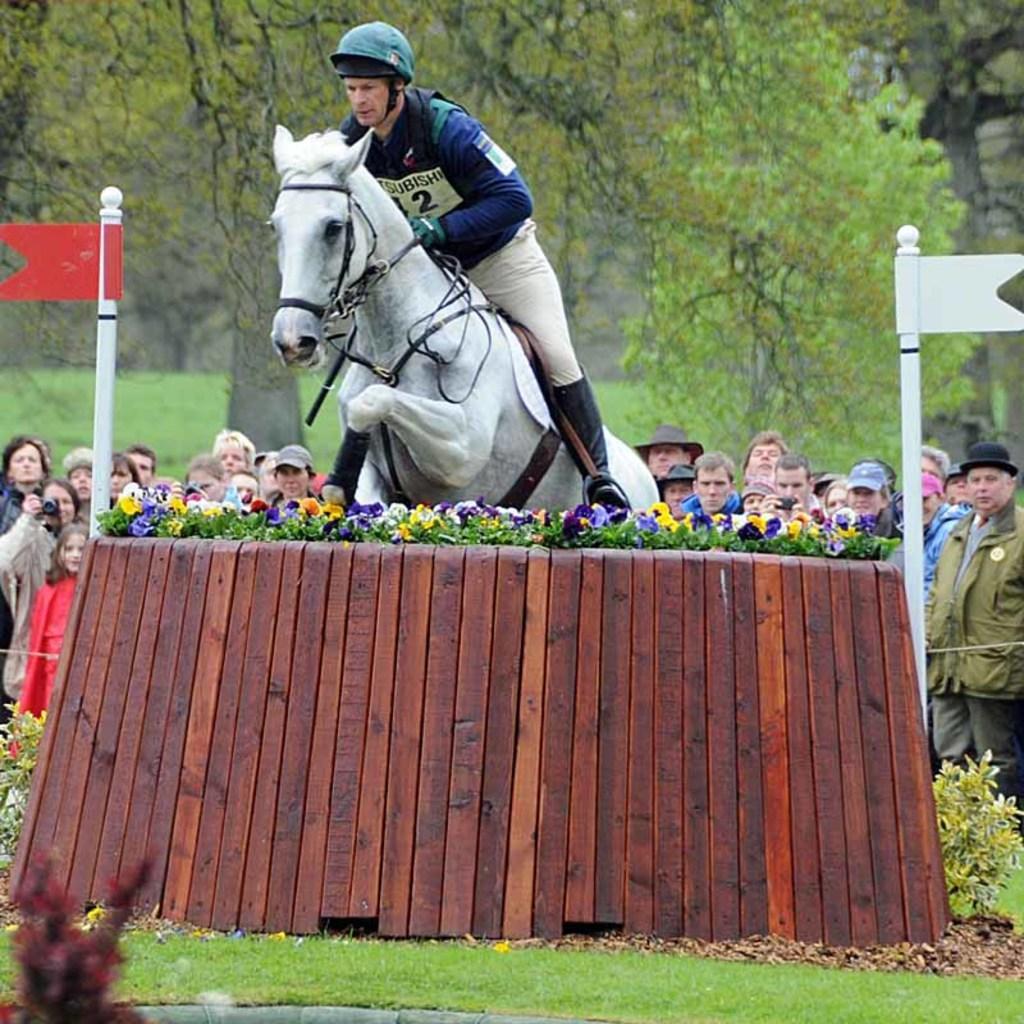In one or two sentences, can you explain what this image depicts? Here we can see a man riding a horse and jumping through a flower barricade and behind him there are people watching it and there are trees all over there 